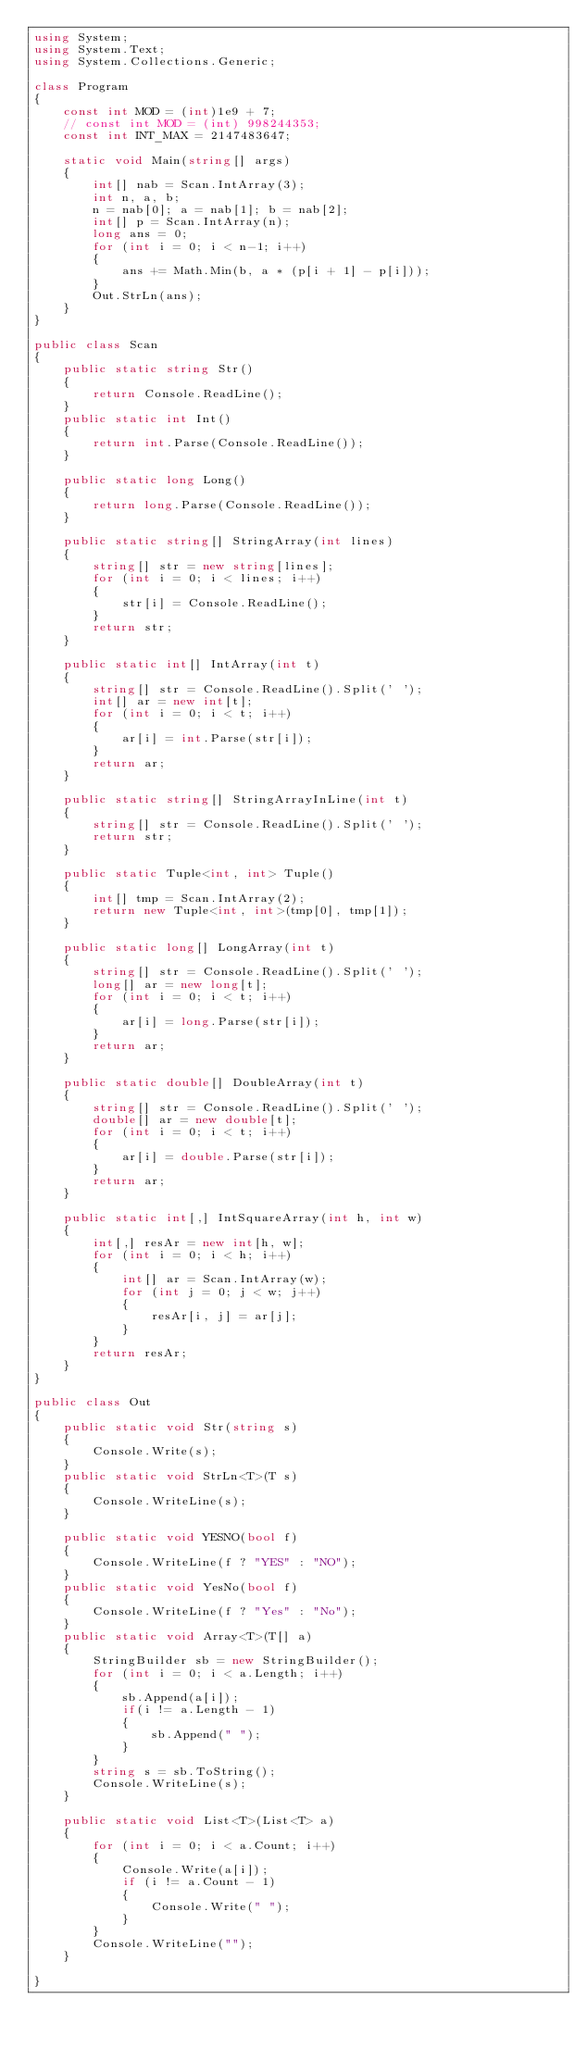<code> <loc_0><loc_0><loc_500><loc_500><_C#_>using System;
using System.Text;
using System.Collections.Generic;

class Program
{
    const int MOD = (int)1e9 + 7;
    // const int MOD = (int) 998244353;
    const int INT_MAX = 2147483647;

    static void Main(string[] args)
    {
        int[] nab = Scan.IntArray(3);
        int n, a, b;
        n = nab[0]; a = nab[1]; b = nab[2];
        int[] p = Scan.IntArray(n);
        long ans = 0;
        for (int i = 0; i < n-1; i++)
        {
            ans += Math.Min(b, a * (p[i + 1] - p[i]));
        }
        Out.StrLn(ans);
    }
}

public class Scan
{
    public static string Str()
    {
        return Console.ReadLine();
    }
    public static int Int()
    {
        return int.Parse(Console.ReadLine());
    }

    public static long Long()
    {
        return long.Parse(Console.ReadLine());
    }

    public static string[] StringArray(int lines)
    {
        string[] str = new string[lines];
        for (int i = 0; i < lines; i++)
        {
            str[i] = Console.ReadLine();
        }
        return str;
    }

    public static int[] IntArray(int t)
    {
        string[] str = Console.ReadLine().Split(' ');
        int[] ar = new int[t];
        for (int i = 0; i < t; i++)
        {
            ar[i] = int.Parse(str[i]);
        }
        return ar;
    }

    public static string[] StringArrayInLine(int t)
    {
        string[] str = Console.ReadLine().Split(' ');
        return str;
    }

    public static Tuple<int, int> Tuple()
    {
        int[] tmp = Scan.IntArray(2);
        return new Tuple<int, int>(tmp[0], tmp[1]);
    }

    public static long[] LongArray(int t)
    {
        string[] str = Console.ReadLine().Split(' ');
        long[] ar = new long[t];
        for (int i = 0; i < t; i++)
        {
            ar[i] = long.Parse(str[i]);
        }
        return ar;
    }

    public static double[] DoubleArray(int t)
    {
        string[] str = Console.ReadLine().Split(' ');
        double[] ar = new double[t];
        for (int i = 0; i < t; i++)
        {
            ar[i] = double.Parse(str[i]);
        }
        return ar;
    }

    public static int[,] IntSquareArray(int h, int w)
    {
        int[,] resAr = new int[h, w];
        for (int i = 0; i < h; i++)
        {
            int[] ar = Scan.IntArray(w);
            for (int j = 0; j < w; j++)
            {
                resAr[i, j] = ar[j];
            }
        }
        return resAr;
    }
}

public class Out
{
    public static void Str(string s)
    {
        Console.Write(s);
    }
    public static void StrLn<T>(T s)
    {
        Console.WriteLine(s);
    }

    public static void YESNO(bool f)
    {
        Console.WriteLine(f ? "YES" : "NO");
    }
    public static void YesNo(bool f)
    {
        Console.WriteLine(f ? "Yes" : "No");
    }
    public static void Array<T>(T[] a)
    {
        StringBuilder sb = new StringBuilder();
        for (int i = 0; i < a.Length; i++)
        {
            sb.Append(a[i]);
            if(i != a.Length - 1)
            {
                sb.Append(" ");
            }
        }
        string s = sb.ToString();
        Console.WriteLine(s);
    }

    public static void List<T>(List<T> a)
    {
        for (int i = 0; i < a.Count; i++)
        {
            Console.Write(a[i]);
            if (i != a.Count - 1)
            {
                Console.Write(" ");
            }
        }
        Console.WriteLine("");
    }

}</code> 